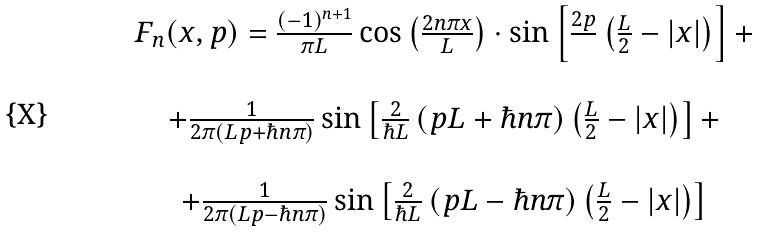Convert formula to latex. <formula><loc_0><loc_0><loc_500><loc_500>\begin{array} { c } F _ { n } ( x , p ) = \frac { ( - 1 ) ^ { n + 1 } } { \pi L } \cos \left ( \frac { 2 n \pi x } { L } \right ) \cdot \sin \left [ \frac { 2 p } { } \left ( \frac { L } { 2 } - | x | \right ) \right ] + \\ \\ + \frac { 1 } { 2 \pi \left ( L p + \hbar { n } \pi \right ) } \sin \left [ \frac { 2 } { \hbar { L } } \left ( p L + \hbar { n } \pi \right ) \left ( \frac { L } { 2 } - | x | \right ) \right ] + \\ \\ + \frac { 1 } { 2 \pi \left ( L p - \hbar { n } \pi \right ) } \sin \left [ \frac { 2 } { \hbar { L } } \left ( p L - \hbar { n } \pi \right ) \left ( \frac { L } { 2 } - | x | \right ) \right ] \end{array}</formula> 